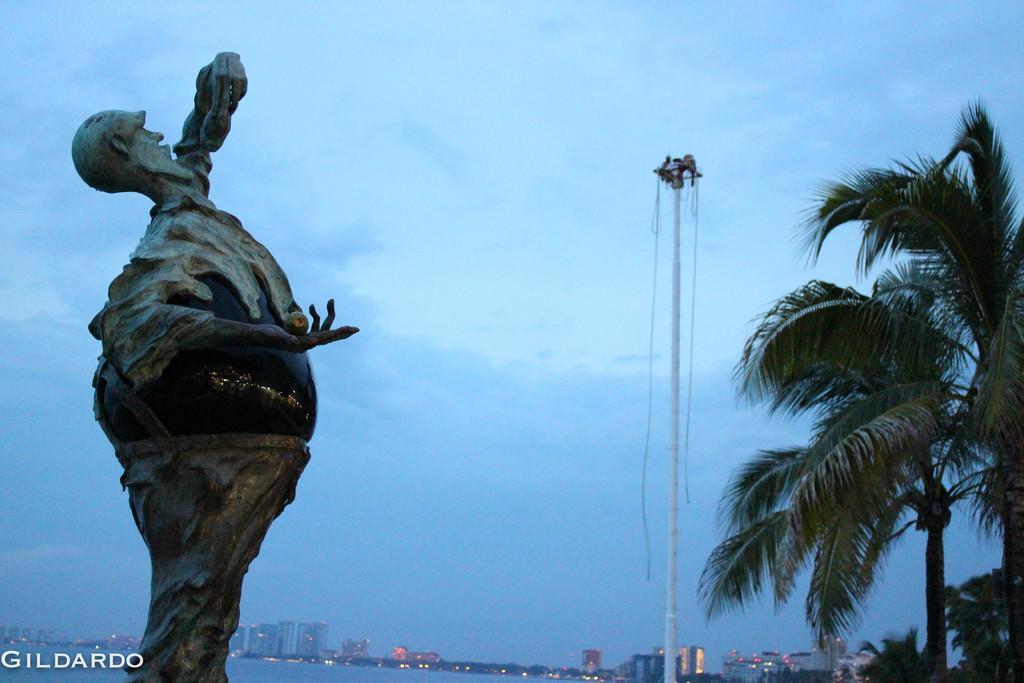What is the main subject of the picture? The main subject of the picture is a sculpture. What other elements can be seen in the picture? There is a tree, buildings, and lights visible in the picture. What type of news can be heard coming from the sculpture in the image? There is no indication in the image that the sculpture is producing or broadcasting any news, so it cannot be determined from the picture. 